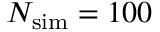Convert formula to latex. <formula><loc_0><loc_0><loc_500><loc_500>N _ { s i m } = 1 0 0</formula> 